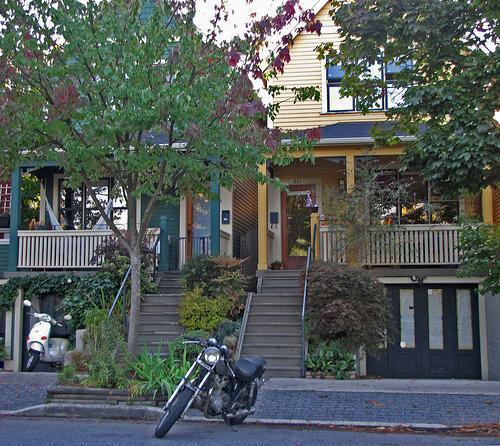How many houses are there?
Give a very brief answer. 2. How many mailboxes are there?
Give a very brief answer. 2. How many motorcycles are parked off the street?
Give a very brief answer. 1. 